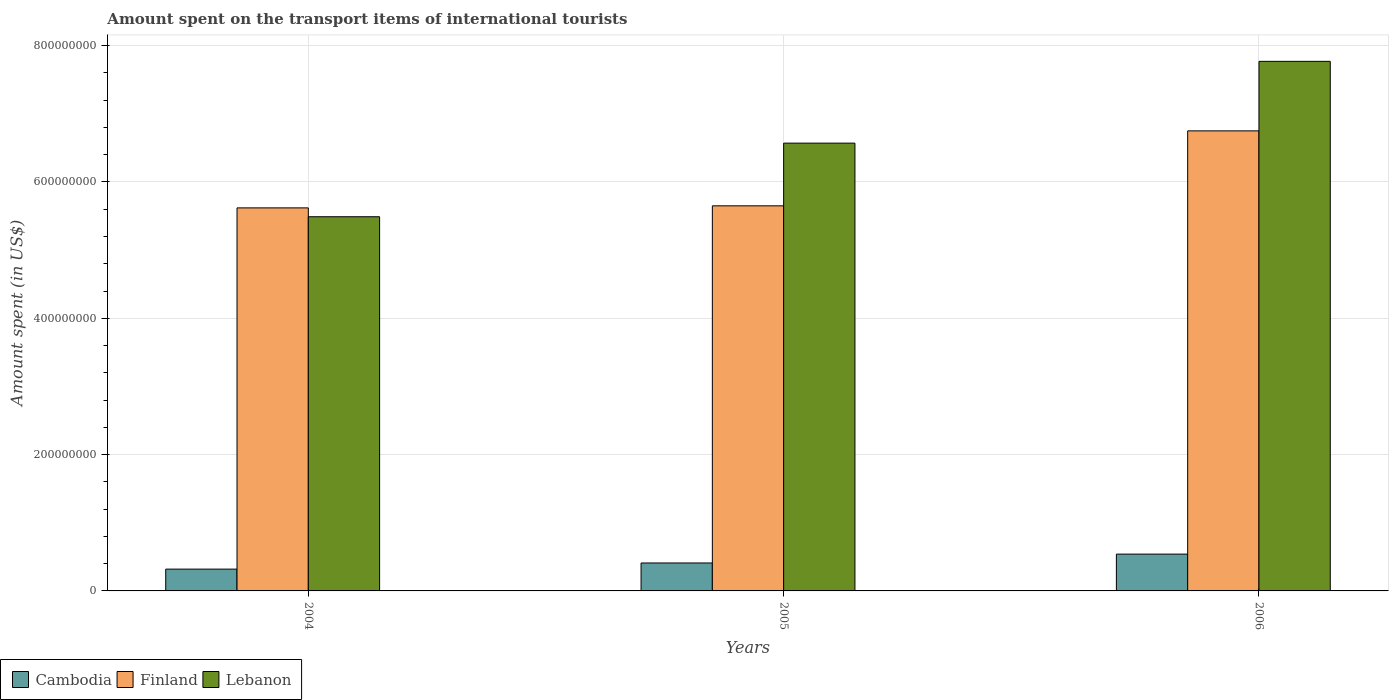How many different coloured bars are there?
Offer a terse response. 3. Are the number of bars per tick equal to the number of legend labels?
Offer a very short reply. Yes. How many bars are there on the 1st tick from the right?
Your answer should be compact. 3. What is the label of the 1st group of bars from the left?
Your answer should be compact. 2004. In how many cases, is the number of bars for a given year not equal to the number of legend labels?
Offer a terse response. 0. What is the amount spent on the transport items of international tourists in Cambodia in 2006?
Your answer should be very brief. 5.40e+07. Across all years, what is the maximum amount spent on the transport items of international tourists in Lebanon?
Offer a very short reply. 7.77e+08. Across all years, what is the minimum amount spent on the transport items of international tourists in Cambodia?
Ensure brevity in your answer.  3.20e+07. In which year was the amount spent on the transport items of international tourists in Finland maximum?
Your response must be concise. 2006. What is the total amount spent on the transport items of international tourists in Lebanon in the graph?
Make the answer very short. 1.98e+09. What is the difference between the amount spent on the transport items of international tourists in Cambodia in 2004 and that in 2005?
Your answer should be compact. -9.00e+06. What is the difference between the amount spent on the transport items of international tourists in Lebanon in 2005 and the amount spent on the transport items of international tourists in Cambodia in 2004?
Your response must be concise. 6.25e+08. What is the average amount spent on the transport items of international tourists in Cambodia per year?
Offer a terse response. 4.23e+07. In the year 2005, what is the difference between the amount spent on the transport items of international tourists in Cambodia and amount spent on the transport items of international tourists in Finland?
Your response must be concise. -5.24e+08. What is the ratio of the amount spent on the transport items of international tourists in Finland in 2004 to that in 2005?
Your answer should be compact. 0.99. Is the amount spent on the transport items of international tourists in Finland in 2004 less than that in 2005?
Offer a terse response. Yes. What is the difference between the highest and the second highest amount spent on the transport items of international tourists in Cambodia?
Make the answer very short. 1.30e+07. What is the difference between the highest and the lowest amount spent on the transport items of international tourists in Cambodia?
Offer a terse response. 2.20e+07. What does the 1st bar from the left in 2005 represents?
Your answer should be compact. Cambodia. What does the 3rd bar from the right in 2005 represents?
Your answer should be compact. Cambodia. Is it the case that in every year, the sum of the amount spent on the transport items of international tourists in Lebanon and amount spent on the transport items of international tourists in Finland is greater than the amount spent on the transport items of international tourists in Cambodia?
Offer a very short reply. Yes. How many bars are there?
Your answer should be compact. 9. Are all the bars in the graph horizontal?
Your answer should be very brief. No. How many years are there in the graph?
Make the answer very short. 3. What is the difference between two consecutive major ticks on the Y-axis?
Give a very brief answer. 2.00e+08. Are the values on the major ticks of Y-axis written in scientific E-notation?
Give a very brief answer. No. Does the graph contain any zero values?
Provide a succinct answer. No. Where does the legend appear in the graph?
Your response must be concise. Bottom left. How are the legend labels stacked?
Your response must be concise. Horizontal. What is the title of the graph?
Your answer should be compact. Amount spent on the transport items of international tourists. Does "Hungary" appear as one of the legend labels in the graph?
Your answer should be compact. No. What is the label or title of the X-axis?
Offer a very short reply. Years. What is the label or title of the Y-axis?
Offer a very short reply. Amount spent (in US$). What is the Amount spent (in US$) of Cambodia in 2004?
Ensure brevity in your answer.  3.20e+07. What is the Amount spent (in US$) in Finland in 2004?
Offer a very short reply. 5.62e+08. What is the Amount spent (in US$) in Lebanon in 2004?
Keep it short and to the point. 5.49e+08. What is the Amount spent (in US$) in Cambodia in 2005?
Provide a succinct answer. 4.10e+07. What is the Amount spent (in US$) of Finland in 2005?
Provide a short and direct response. 5.65e+08. What is the Amount spent (in US$) in Lebanon in 2005?
Keep it short and to the point. 6.57e+08. What is the Amount spent (in US$) of Cambodia in 2006?
Provide a short and direct response. 5.40e+07. What is the Amount spent (in US$) of Finland in 2006?
Offer a very short reply. 6.75e+08. What is the Amount spent (in US$) of Lebanon in 2006?
Provide a short and direct response. 7.77e+08. Across all years, what is the maximum Amount spent (in US$) of Cambodia?
Your answer should be compact. 5.40e+07. Across all years, what is the maximum Amount spent (in US$) in Finland?
Make the answer very short. 6.75e+08. Across all years, what is the maximum Amount spent (in US$) of Lebanon?
Provide a succinct answer. 7.77e+08. Across all years, what is the minimum Amount spent (in US$) of Cambodia?
Provide a succinct answer. 3.20e+07. Across all years, what is the minimum Amount spent (in US$) in Finland?
Keep it short and to the point. 5.62e+08. Across all years, what is the minimum Amount spent (in US$) of Lebanon?
Provide a succinct answer. 5.49e+08. What is the total Amount spent (in US$) in Cambodia in the graph?
Your answer should be compact. 1.27e+08. What is the total Amount spent (in US$) in Finland in the graph?
Offer a terse response. 1.80e+09. What is the total Amount spent (in US$) of Lebanon in the graph?
Make the answer very short. 1.98e+09. What is the difference between the Amount spent (in US$) of Cambodia in 2004 and that in 2005?
Ensure brevity in your answer.  -9.00e+06. What is the difference between the Amount spent (in US$) of Lebanon in 2004 and that in 2005?
Ensure brevity in your answer.  -1.08e+08. What is the difference between the Amount spent (in US$) in Cambodia in 2004 and that in 2006?
Provide a succinct answer. -2.20e+07. What is the difference between the Amount spent (in US$) of Finland in 2004 and that in 2006?
Offer a terse response. -1.13e+08. What is the difference between the Amount spent (in US$) of Lebanon in 2004 and that in 2006?
Offer a terse response. -2.28e+08. What is the difference between the Amount spent (in US$) in Cambodia in 2005 and that in 2006?
Provide a short and direct response. -1.30e+07. What is the difference between the Amount spent (in US$) of Finland in 2005 and that in 2006?
Your answer should be compact. -1.10e+08. What is the difference between the Amount spent (in US$) of Lebanon in 2005 and that in 2006?
Ensure brevity in your answer.  -1.20e+08. What is the difference between the Amount spent (in US$) of Cambodia in 2004 and the Amount spent (in US$) of Finland in 2005?
Offer a terse response. -5.33e+08. What is the difference between the Amount spent (in US$) in Cambodia in 2004 and the Amount spent (in US$) in Lebanon in 2005?
Ensure brevity in your answer.  -6.25e+08. What is the difference between the Amount spent (in US$) in Finland in 2004 and the Amount spent (in US$) in Lebanon in 2005?
Keep it short and to the point. -9.50e+07. What is the difference between the Amount spent (in US$) of Cambodia in 2004 and the Amount spent (in US$) of Finland in 2006?
Your answer should be compact. -6.43e+08. What is the difference between the Amount spent (in US$) of Cambodia in 2004 and the Amount spent (in US$) of Lebanon in 2006?
Give a very brief answer. -7.45e+08. What is the difference between the Amount spent (in US$) in Finland in 2004 and the Amount spent (in US$) in Lebanon in 2006?
Provide a succinct answer. -2.15e+08. What is the difference between the Amount spent (in US$) in Cambodia in 2005 and the Amount spent (in US$) in Finland in 2006?
Ensure brevity in your answer.  -6.34e+08. What is the difference between the Amount spent (in US$) of Cambodia in 2005 and the Amount spent (in US$) of Lebanon in 2006?
Offer a terse response. -7.36e+08. What is the difference between the Amount spent (in US$) of Finland in 2005 and the Amount spent (in US$) of Lebanon in 2006?
Ensure brevity in your answer.  -2.12e+08. What is the average Amount spent (in US$) of Cambodia per year?
Your answer should be very brief. 4.23e+07. What is the average Amount spent (in US$) in Finland per year?
Ensure brevity in your answer.  6.01e+08. What is the average Amount spent (in US$) of Lebanon per year?
Your answer should be compact. 6.61e+08. In the year 2004, what is the difference between the Amount spent (in US$) of Cambodia and Amount spent (in US$) of Finland?
Give a very brief answer. -5.30e+08. In the year 2004, what is the difference between the Amount spent (in US$) in Cambodia and Amount spent (in US$) in Lebanon?
Your response must be concise. -5.17e+08. In the year 2004, what is the difference between the Amount spent (in US$) of Finland and Amount spent (in US$) of Lebanon?
Your answer should be compact. 1.30e+07. In the year 2005, what is the difference between the Amount spent (in US$) of Cambodia and Amount spent (in US$) of Finland?
Keep it short and to the point. -5.24e+08. In the year 2005, what is the difference between the Amount spent (in US$) in Cambodia and Amount spent (in US$) in Lebanon?
Your response must be concise. -6.16e+08. In the year 2005, what is the difference between the Amount spent (in US$) in Finland and Amount spent (in US$) in Lebanon?
Offer a very short reply. -9.20e+07. In the year 2006, what is the difference between the Amount spent (in US$) of Cambodia and Amount spent (in US$) of Finland?
Give a very brief answer. -6.21e+08. In the year 2006, what is the difference between the Amount spent (in US$) of Cambodia and Amount spent (in US$) of Lebanon?
Give a very brief answer. -7.23e+08. In the year 2006, what is the difference between the Amount spent (in US$) of Finland and Amount spent (in US$) of Lebanon?
Offer a terse response. -1.02e+08. What is the ratio of the Amount spent (in US$) in Cambodia in 2004 to that in 2005?
Your answer should be compact. 0.78. What is the ratio of the Amount spent (in US$) in Lebanon in 2004 to that in 2005?
Provide a short and direct response. 0.84. What is the ratio of the Amount spent (in US$) of Cambodia in 2004 to that in 2006?
Ensure brevity in your answer.  0.59. What is the ratio of the Amount spent (in US$) of Finland in 2004 to that in 2006?
Offer a very short reply. 0.83. What is the ratio of the Amount spent (in US$) in Lebanon in 2004 to that in 2006?
Provide a succinct answer. 0.71. What is the ratio of the Amount spent (in US$) in Cambodia in 2005 to that in 2006?
Ensure brevity in your answer.  0.76. What is the ratio of the Amount spent (in US$) of Finland in 2005 to that in 2006?
Your response must be concise. 0.84. What is the ratio of the Amount spent (in US$) in Lebanon in 2005 to that in 2006?
Your response must be concise. 0.85. What is the difference between the highest and the second highest Amount spent (in US$) in Cambodia?
Ensure brevity in your answer.  1.30e+07. What is the difference between the highest and the second highest Amount spent (in US$) of Finland?
Keep it short and to the point. 1.10e+08. What is the difference between the highest and the second highest Amount spent (in US$) in Lebanon?
Keep it short and to the point. 1.20e+08. What is the difference between the highest and the lowest Amount spent (in US$) in Cambodia?
Your response must be concise. 2.20e+07. What is the difference between the highest and the lowest Amount spent (in US$) in Finland?
Make the answer very short. 1.13e+08. What is the difference between the highest and the lowest Amount spent (in US$) in Lebanon?
Offer a very short reply. 2.28e+08. 